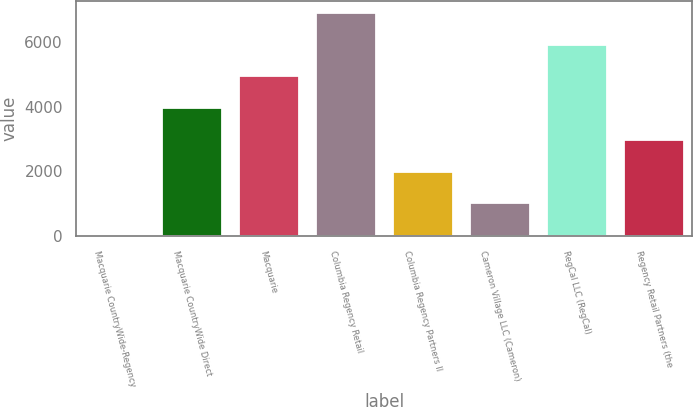Convert chart to OTSL. <chart><loc_0><loc_0><loc_500><loc_500><bar_chart><fcel>Macquarie CountryWide-Regency<fcel>Macquarie CountryWide Direct<fcel>Macquarie<fcel>Columbia Regency Retail<fcel>Columbia Regency Partners II<fcel>Cameron Village LLC (Cameron)<fcel>RegCal LLC (RegCal)<fcel>Regency Retail Partners (the<nl><fcel>67<fcel>3988.6<fcel>4969<fcel>6929.8<fcel>2027.8<fcel>1047.4<fcel>5949.4<fcel>3008.2<nl></chart> 